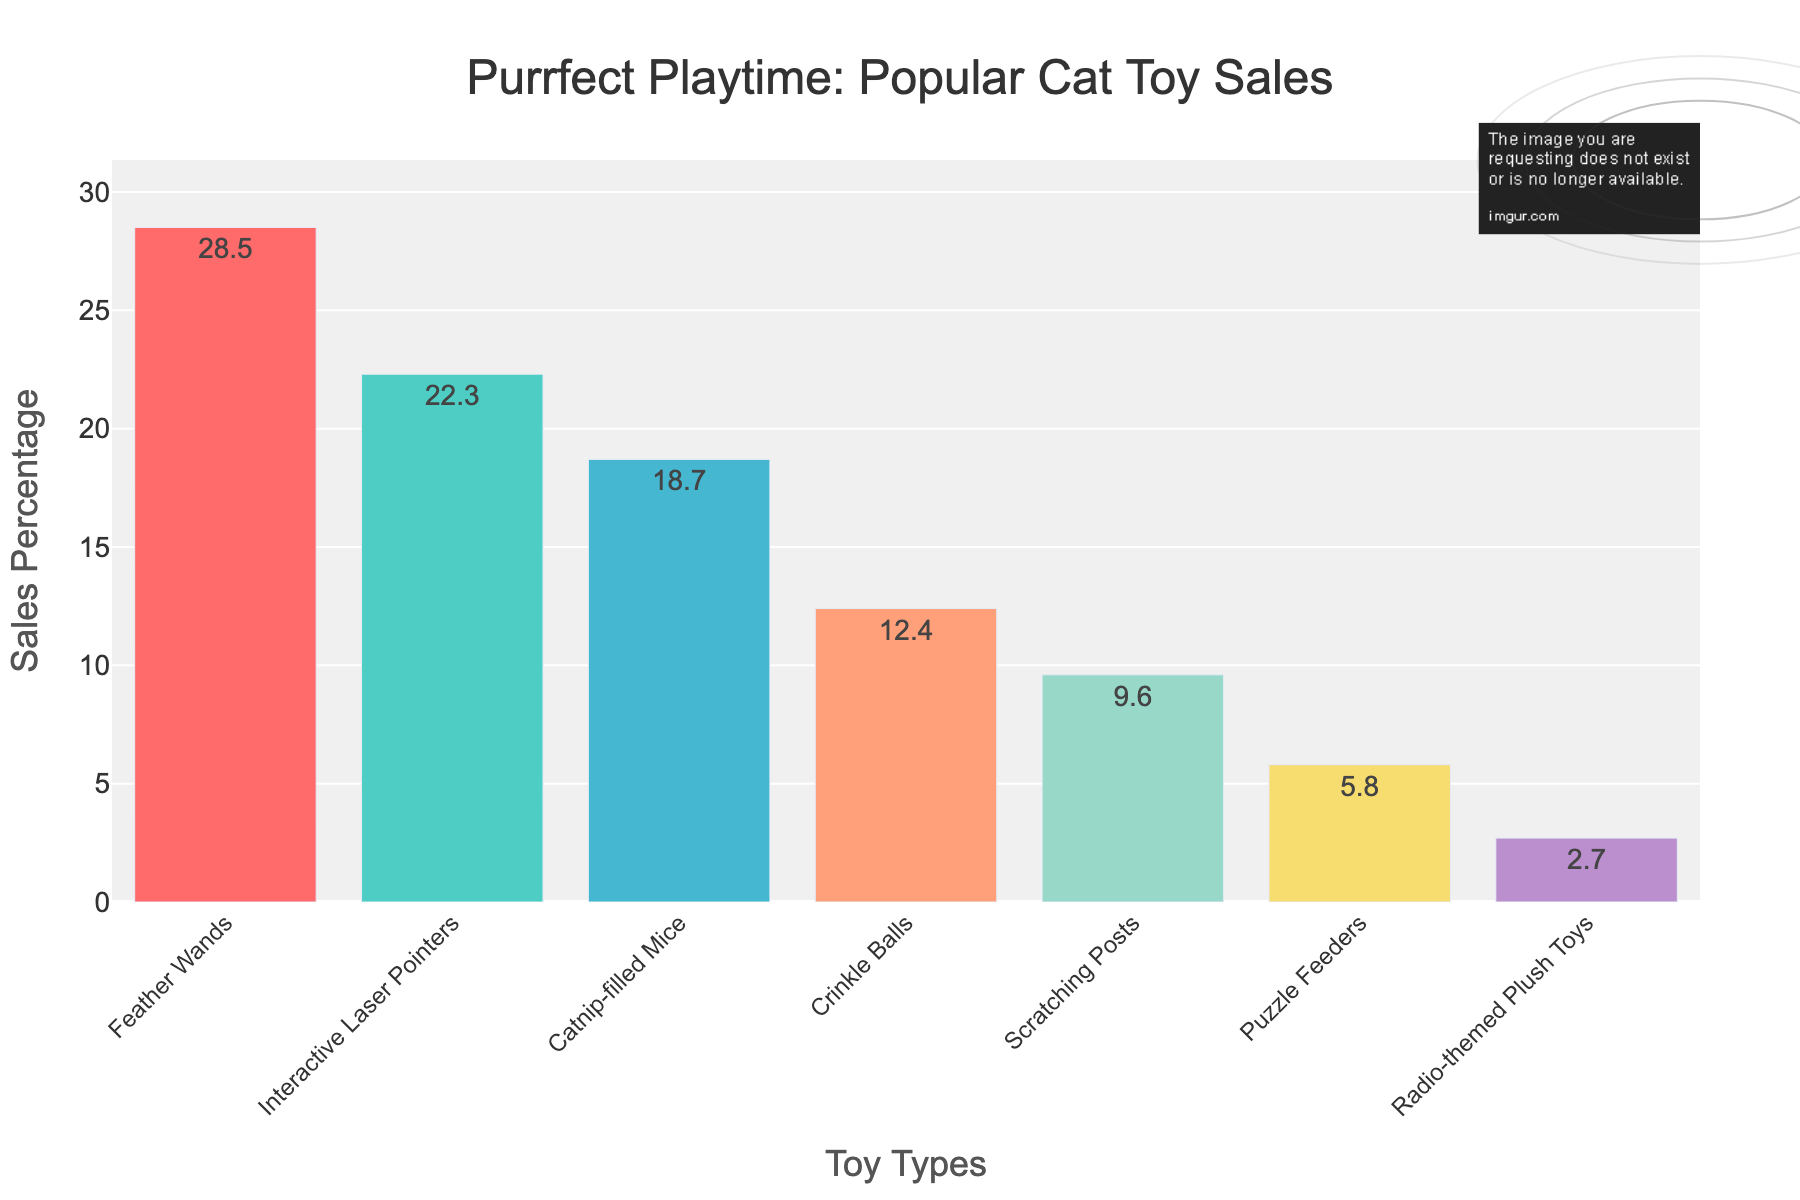What is the sales percentage of Feather Wands? The sales percentage for Feather Wands is displayed as a bar in the chart. By reading the text on the bar above Feather Wands, we find it.
Answer: 28.5% Which toy type has the second highest sales percentage? We observe the heights and labels of the bars in the chart. The tallest bar represents Feather Wands, followed by the next tallest which is for Interactive Laser Pointers.
Answer: Interactive Laser Pointers How much higher is the sales percentage of Feather Wands compared to Radio-themed Plush Toys? By reading the sales percentages for Feather Wands (28.5%) and Radio-themed Plush Toys (2.7%), we subtract the smaller value from the larger value: 28.5 - 2.7.
Answer: 25.8% What is the combined sales percentage of Scratching Posts and Puzzle Feeders? Adding the sales percentages shown for Scratching Posts (9.6%) and Puzzle Feeders (5.8%) gives the combined value.
Answer: 15.4% Which toy type has the lowest sales percentage? Looking at the shortest bar in the chart, we determine that Radio-themed Plush Toys have the lowest sales percentage.
Answer: Radio-themed Plush Toys Are Feather Wands' sales significantly higher than Catnip-filled Mice? Comparing their sales percentages, Feather Wands have 28.5% and Catnip-filled Mice have 18.7%. The difference is calculated as 28.5 - 18.7, which is significant.
Answer: Yes What is the average sales percentage of the top three selling toy types? The top three toy types are Feather Wands (28.5%), Interactive Laser Pointers (22.3%), and Catnip-filled Mice (18.7%). Average = (28.5 + 22.3 + 18.7) / 3.
Answer: 23.17% How does the sales percentage of Crinkle Balls compare to that of Scratching Posts? Comparing the sales percentages of Crinkle Balls (12.4%) and Scratching Posts (9.6%) shows that Crinkle Balls have a higher percentage.
Answer: Crinkle Balls have higher sales What is the total sales percentage of all the toy types combined? By summing the sales percentages of all the toy types: 28.5 + 22.3 + 18.7 + 12.4 + 9.6 + 5.8 + 2.7.
Answer: 100% What color represents the sales percentage for Puzzle Feeders? Observing the bar representing Puzzle Feeders in the chart reveals the bar's color.
Answer: Yellowish (golden) 